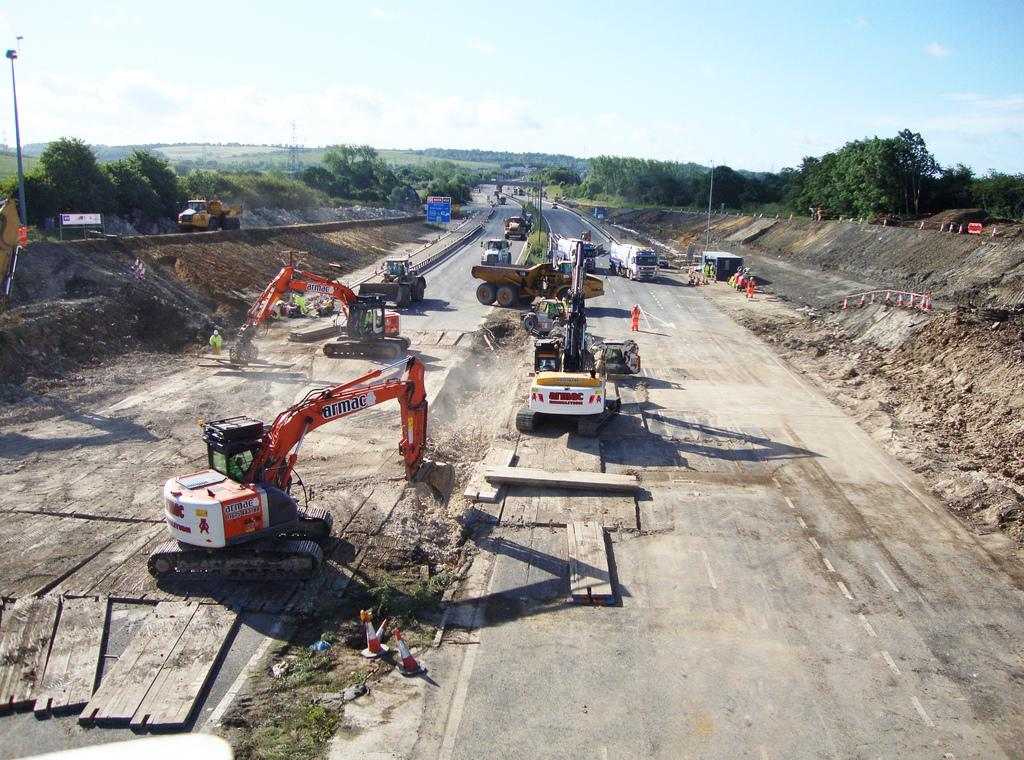What type of vehicles can be seen in the image? There are cranes and lorries in the image. Where are the vehicles located? The vehicles are on a road in the image. What can be seen on either side of the road? There are trees and plants on either side of the road. What is visible in the background of the image? There is a sky visible in the background of the image. Can you tell me how many dogs are present in the image? There are no dogs present in the image; it features cranes, lorries, trees, plants, and a sky. Are there any lizards visible in the image? There are no lizards visible in the image. 